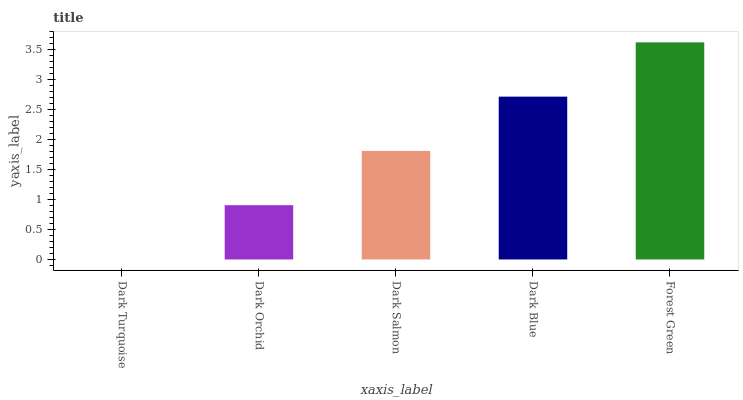Is Dark Turquoise the minimum?
Answer yes or no. Yes. Is Forest Green the maximum?
Answer yes or no. Yes. Is Dark Orchid the minimum?
Answer yes or no. No. Is Dark Orchid the maximum?
Answer yes or no. No. Is Dark Orchid greater than Dark Turquoise?
Answer yes or no. Yes. Is Dark Turquoise less than Dark Orchid?
Answer yes or no. Yes. Is Dark Turquoise greater than Dark Orchid?
Answer yes or no. No. Is Dark Orchid less than Dark Turquoise?
Answer yes or no. No. Is Dark Salmon the high median?
Answer yes or no. Yes. Is Dark Salmon the low median?
Answer yes or no. Yes. Is Forest Green the high median?
Answer yes or no. No. Is Forest Green the low median?
Answer yes or no. No. 